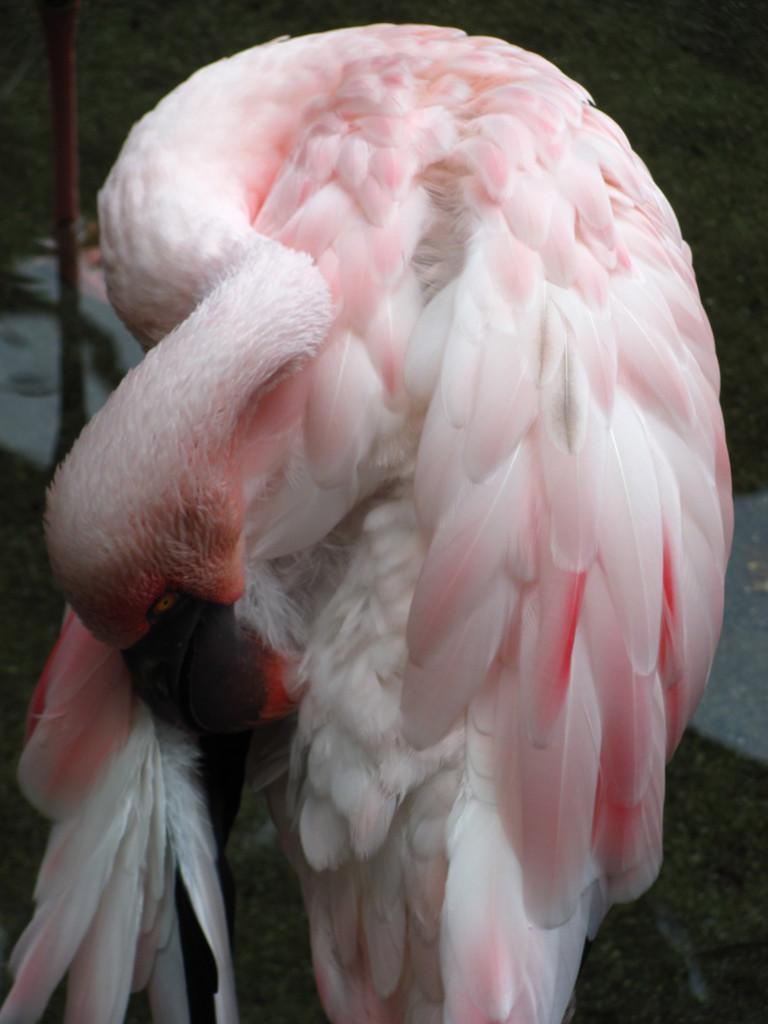What type of animal can be seen in the image? There is a white color bird in the image. What is the color of the bird? The bird is white. What can be observed about the background of the image? The background of the image is dark. What type of eggnog is being served in the image? There is no eggnog present in the image; it only features a white color bird with a dark background. 